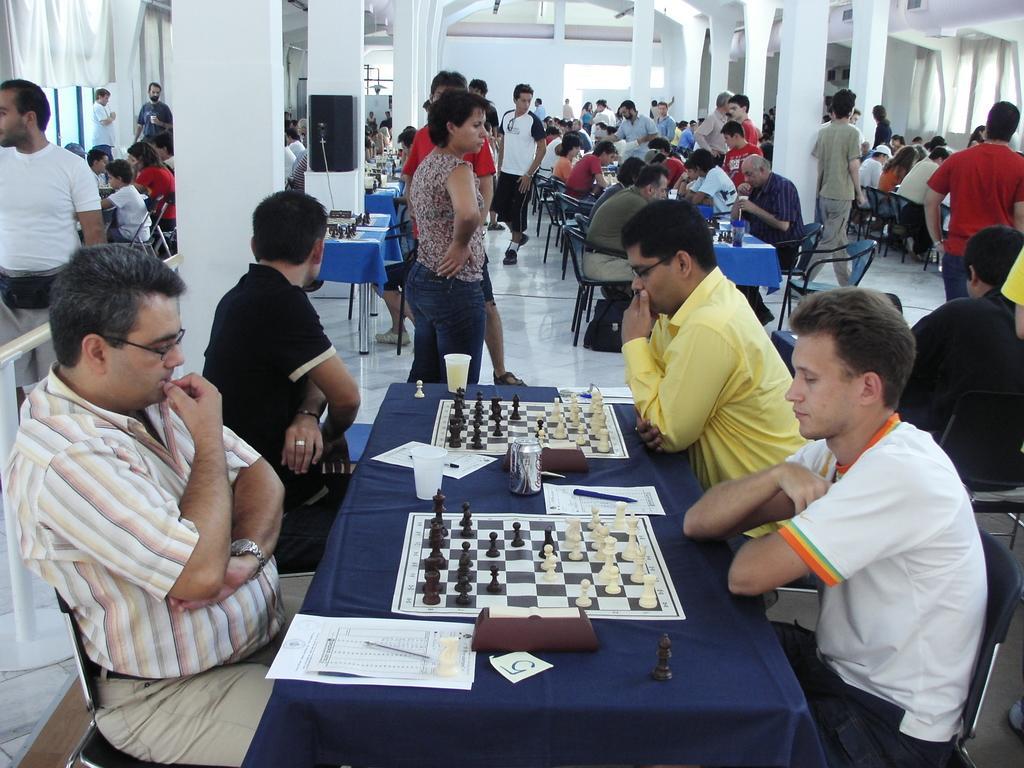How would you summarize this image in a sentence or two? In this image i can see there are group of people and some are standing on the floor. In front of the image we can see there are four people sitting on the chair playing the chess on the table. We can see there are two chess boards and white paper with a pen on it. In the background of the image we can see few pillars of the building and the person wearing white t shirt is walking on the floor. 